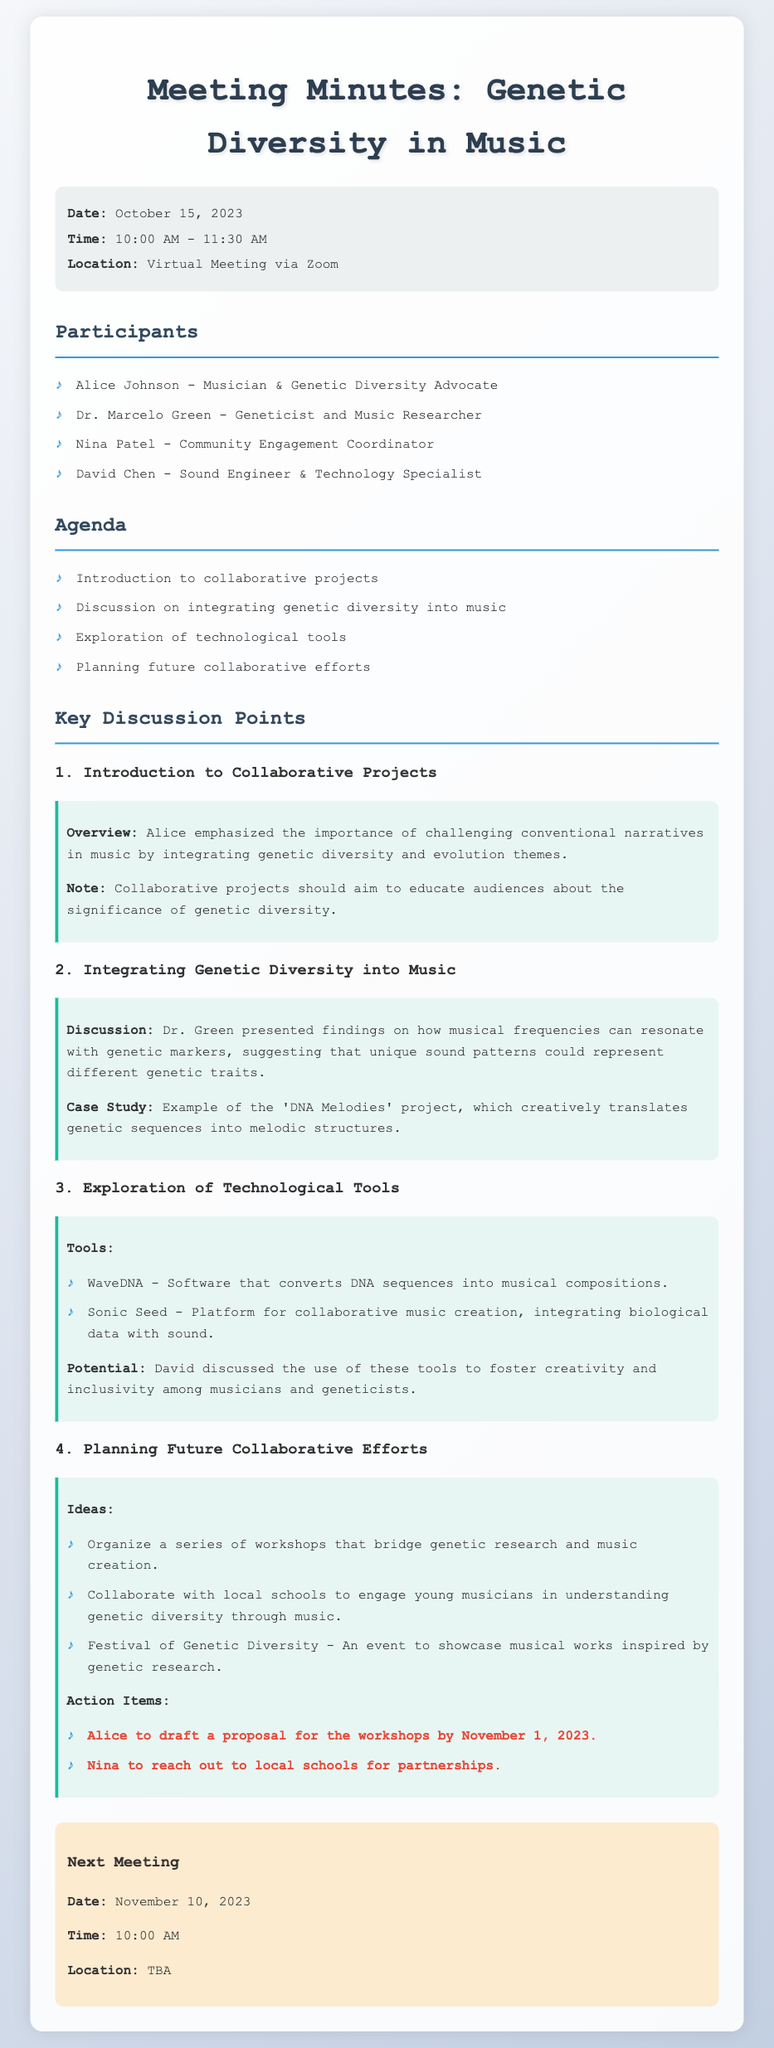What is the date of the meeting? The date of the meeting is specified in the meta-info section of the document.
Answer: October 15, 2023 Who presented findings on how musical frequencies can resonate with genetic markers? The document indicates that Dr. Green presented these findings.
Answer: Dr. Marcelo Green What tool converts DNA sequences into musical compositions? The document lists WaveDNA as a tool that performs this function.
Answer: WaveDNA What is one action item assigned to Alice? The action item for Alice is detailed in the planning future collaborative efforts section.
Answer: Draft a proposal for the workshops by November 1, 2023 Which event is planned to showcase musical works inspired by genetic research? The document mentions the Festival of Genetic Diversity as an event for this purpose.
Answer: Festival of Genetic Diversity How long did the meeting last? The duration of the meeting can be calculated from the given start and end times.
Answer: 1 hour 30 minutes What organization is Nina Patel associated with? The document lists Nina Patel's role in conjunction with the discussion topics.
Answer: Community Engagement Coordinator When is the next meeting scheduled? The next meeting date is specified under the next meeting section of the document.
Answer: November 10, 2023 